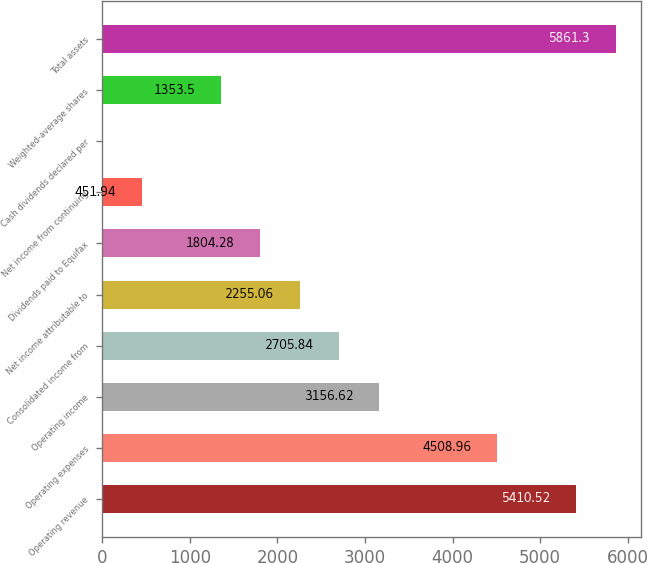<chart> <loc_0><loc_0><loc_500><loc_500><bar_chart><fcel>Operating revenue<fcel>Operating expenses<fcel>Operating income<fcel>Consolidated income from<fcel>Net income attributable to<fcel>Dividends paid to Equifax<fcel>Net income from continuing<fcel>Cash dividends declared per<fcel>Weighted-average shares<fcel>Total assets<nl><fcel>5410.52<fcel>4508.96<fcel>3156.62<fcel>2705.84<fcel>2255.06<fcel>1804.28<fcel>451.94<fcel>1.16<fcel>1353.5<fcel>5861.3<nl></chart> 